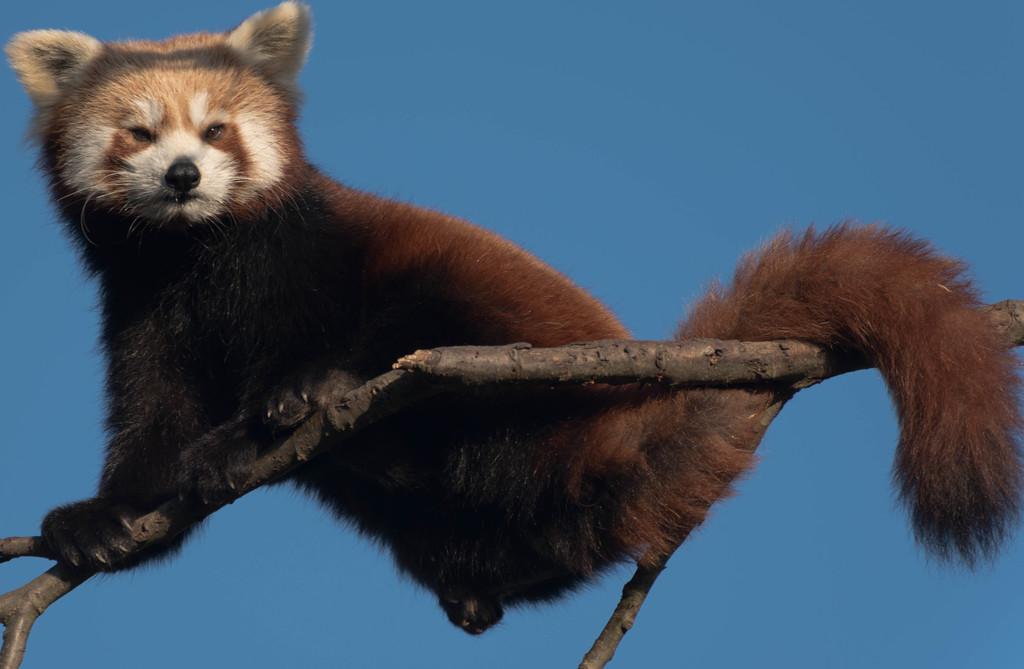How would you summarize this image in a sentence or two? On the left side, there is an animal on a branch of a tree. And the background is blue in color. 